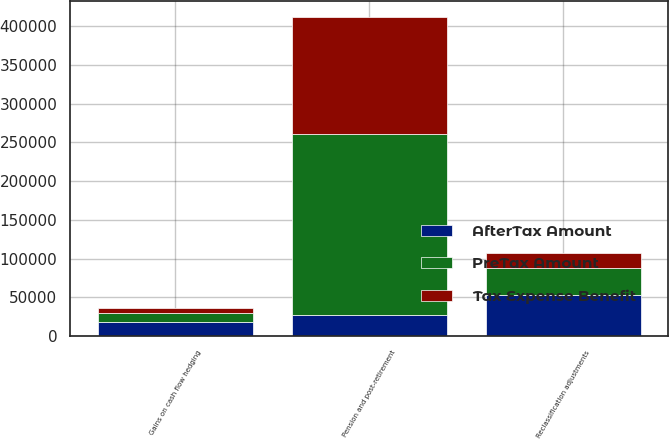Convert chart to OTSL. <chart><loc_0><loc_0><loc_500><loc_500><stacked_bar_chart><ecel><fcel>Pension and post-retirement<fcel>Gains on cash flow hedging<fcel>Reclassification adjustments<nl><fcel>AfterTax Amount<fcel>26648.5<fcel>17886<fcel>53297<nl><fcel>Tax Expense Benefit<fcel>150694<fcel>6390<fcel>19223<nl><fcel>PreTax Amount<fcel>234788<fcel>11496<fcel>34074<nl></chart> 